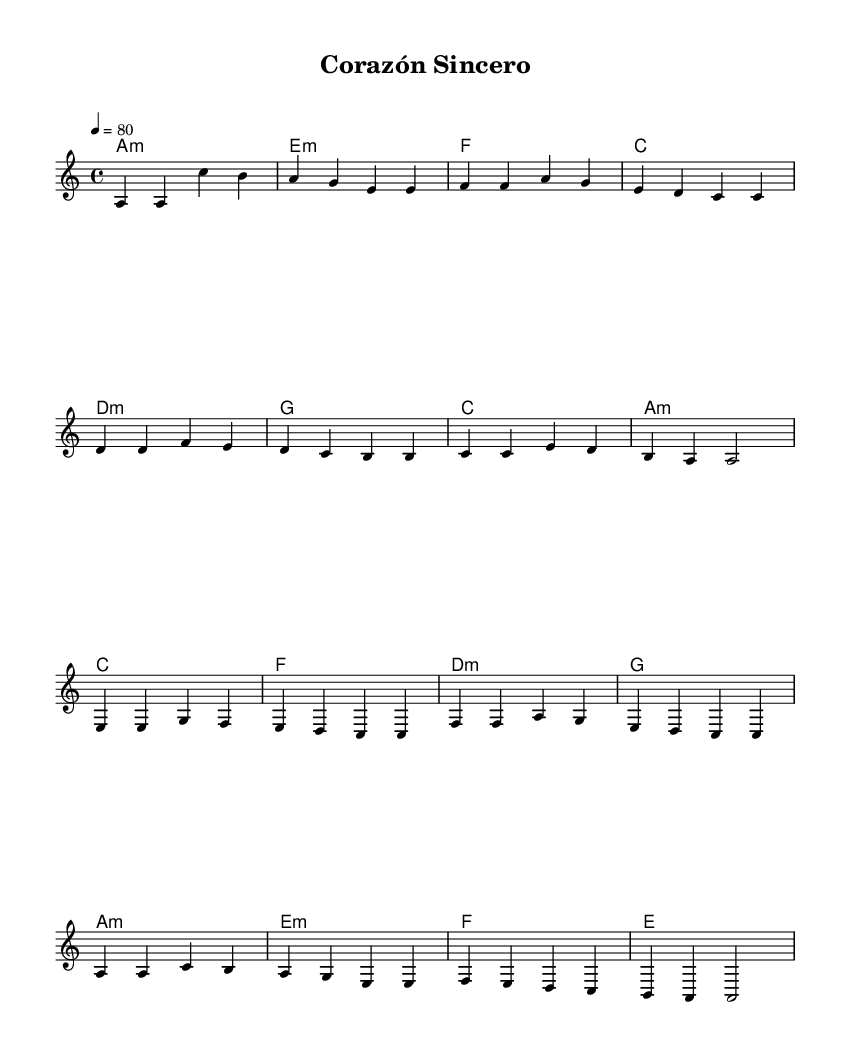What is the key signature of this music? The piece is in the key of A minor, which has no sharps or flats indicated in the key signature. This is determined from the global settings at the top where it specifies \key a \minor.
Answer: A minor What is the time signature of this music? The time signature is 4/4, which means there are four beats per measure and a quarter note gets one beat. This can be found in the global settings section where it mentions \time 4/4.
Answer: 4/4 What is the tempo marking of this piece? The tempo is marked at a quarter note equals 80 beats per minute, indicated in the global section as \tempo 4 = 80. This sets the speed for how quickly the music should be played.
Answer: 80 How many measures are there in the verse? Counting from the melody section of the sheet music, there are a total of 8 measures in the verse part before it transitions to the chorus. This includes each group of notes separated by vertical lines.
Answer: 8 What is the first chord in the piece? The first chord is A minor, indicated by the first entry in the harmonies section labeled as a1:m. This is derived from the chord mode which lists the chords in sequence alongside the melody.
Answer: A minor What is the last note of the chorus? The last note of the chorus is A, represented as a2 in the melody line. It can be found in the melody section towards the end of the chorus notation.
Answer: A How many distinct harmonies are used in the verse? There are 7 distinct harmonies utilized in the verse as indicated by the chords listed: A minor, E minor, F, C, D minor, G, and back to A minor. Each harmony corresponds to each measure in the verse.
Answer: 7 